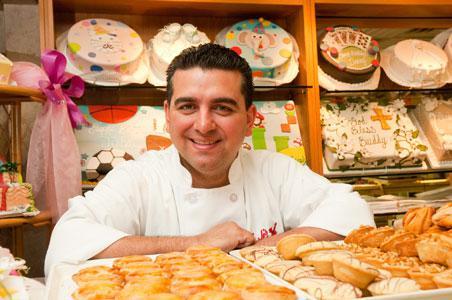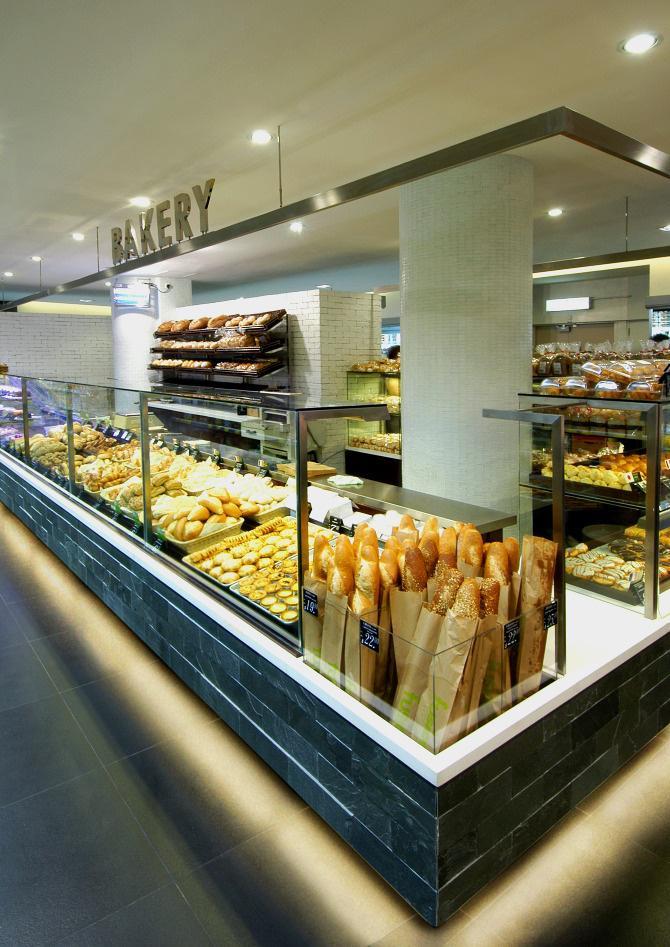The first image is the image on the left, the second image is the image on the right. For the images displayed, is the sentence "One of the shops has tables and chairs out front." factually correct? Answer yes or no. No. The first image is the image on the left, the second image is the image on the right. Assess this claim about the two images: "In at least one image there is a shelve of bake goods inside a bakery.". Correct or not? Answer yes or no. Yes. 